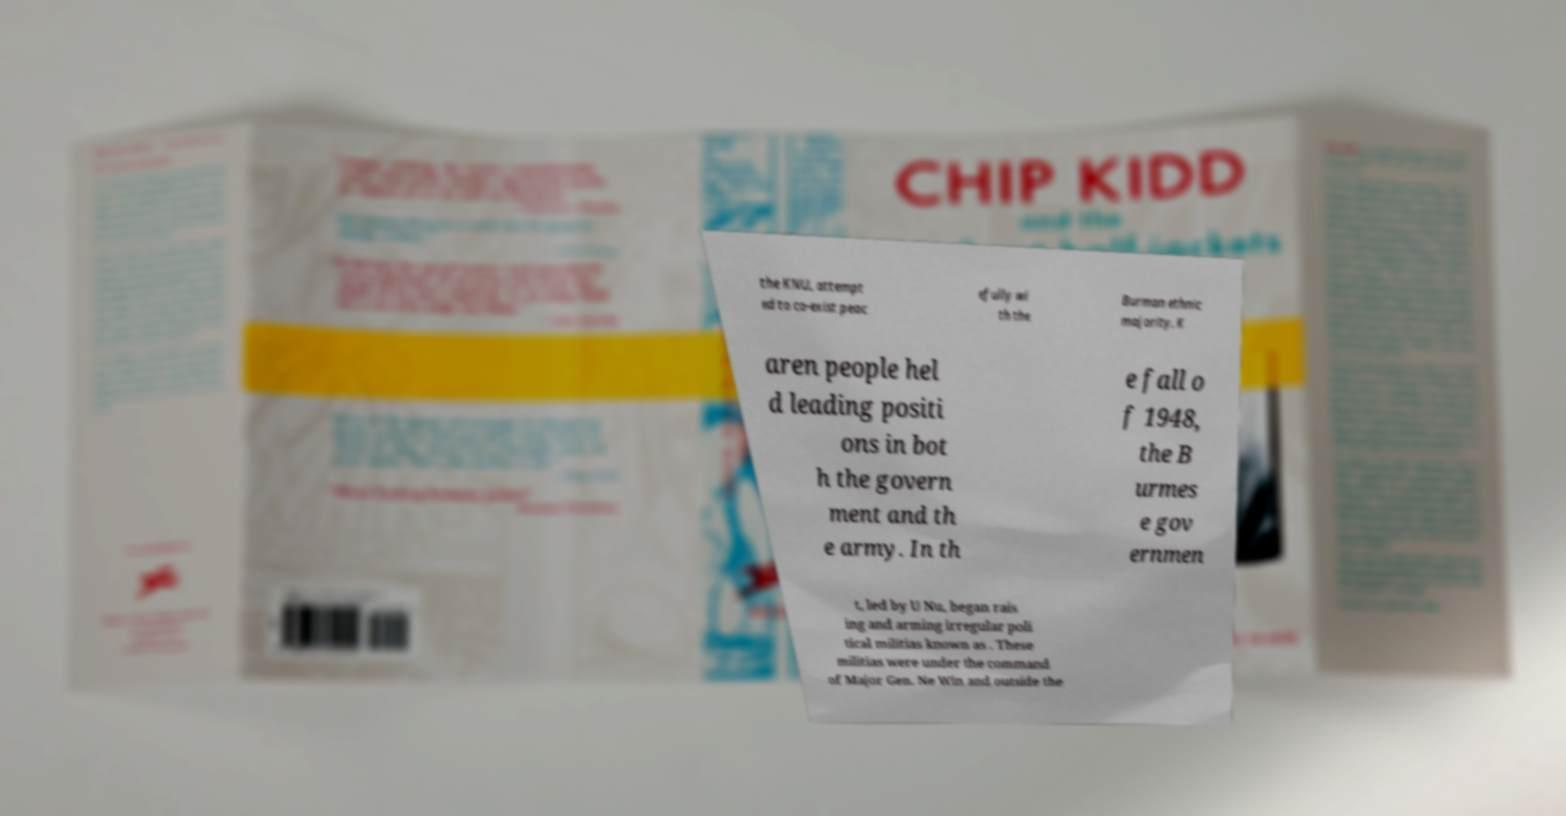I need the written content from this picture converted into text. Can you do that? the KNU, attempt ed to co-exist peac efully wi th the Burman ethnic majority. K aren people hel d leading positi ons in bot h the govern ment and th e army. In th e fall o f 1948, the B urmes e gov ernmen t, led by U Nu, began rais ing and arming irregular poli tical militias known as . These militias were under the command of Major Gen. Ne Win and outside the 